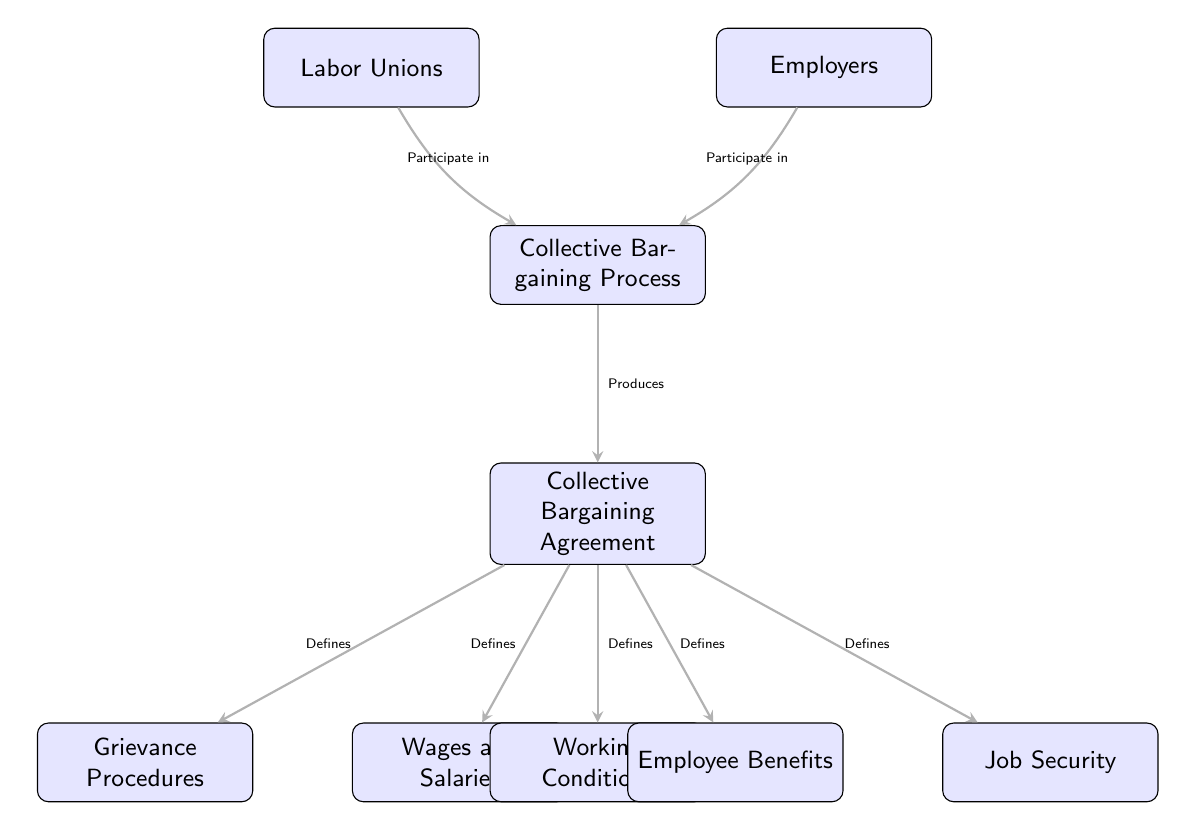What are the two main participants in the collective bargaining process? The diagram identifies "Labor Unions" and "Employers" as the two main participants in the collective bargaining process, placed at the top of the diagram.
Answer: Labor Unions, Employers What does the collective bargaining process produce? In the diagram, it is clearly stated that the collective bargaining process "Produces" a "Collective Bargaining Agreement," indicating its direct outcome.
Answer: Collective Bargaining Agreement What are the five key components defined by the collective bargaining agreement? The diagram shows that the collective bargaining agreement defines "Wages and Salaries," "Working Conditions," "Employee Benefits," "Grievance Procedures," and "Job Security," which are all listed below the agreement node.
Answer: Wages and Salaries, Working Conditions, Employee Benefits, Grievance Procedures, Job Security How many nodes are present in total in this diagram? By counting each labeled data point in the diagram, including all participants, processes, and agreement components, there are a total of 8 nodes identified.
Answer: 8 Which node is positioned directly below the collective bargaining process? The diagram places the "Collective Bargaining Agreement" directly below the "Collective Bargaining Process," indicating its immediate relationship in the hierarchy.
Answer: Collective Bargaining Agreement What role do unions and employers have in the bargaining process? The diagram illustrates that both unions and employers "Participate in" the collective bargaining process, indicating a joint role in negotiating the terms of the agreement.
Answer: Participate in What defines job security according to the diagram? According to the diagram, "Job Security" is defined by the "Collective Bargaining Agreement," which establishes this aspect as part of the agreement's components.
Answer: Collective Bargaining Agreement What is the relationship between the collective bargaining agreement and wages? The diagram indicates a direct relationship where the collective bargaining agreement "Defines" wages, linking the agreement as the source of wage determination.
Answer: Defines How are grievance procedures categorized in relation to the agreement? In the diagram, "Grievance Procedures" are labeled as something that the "Collective Bargaining Agreement" "Defines," indicating its role in addressing workplace issues.
Answer: Defines 